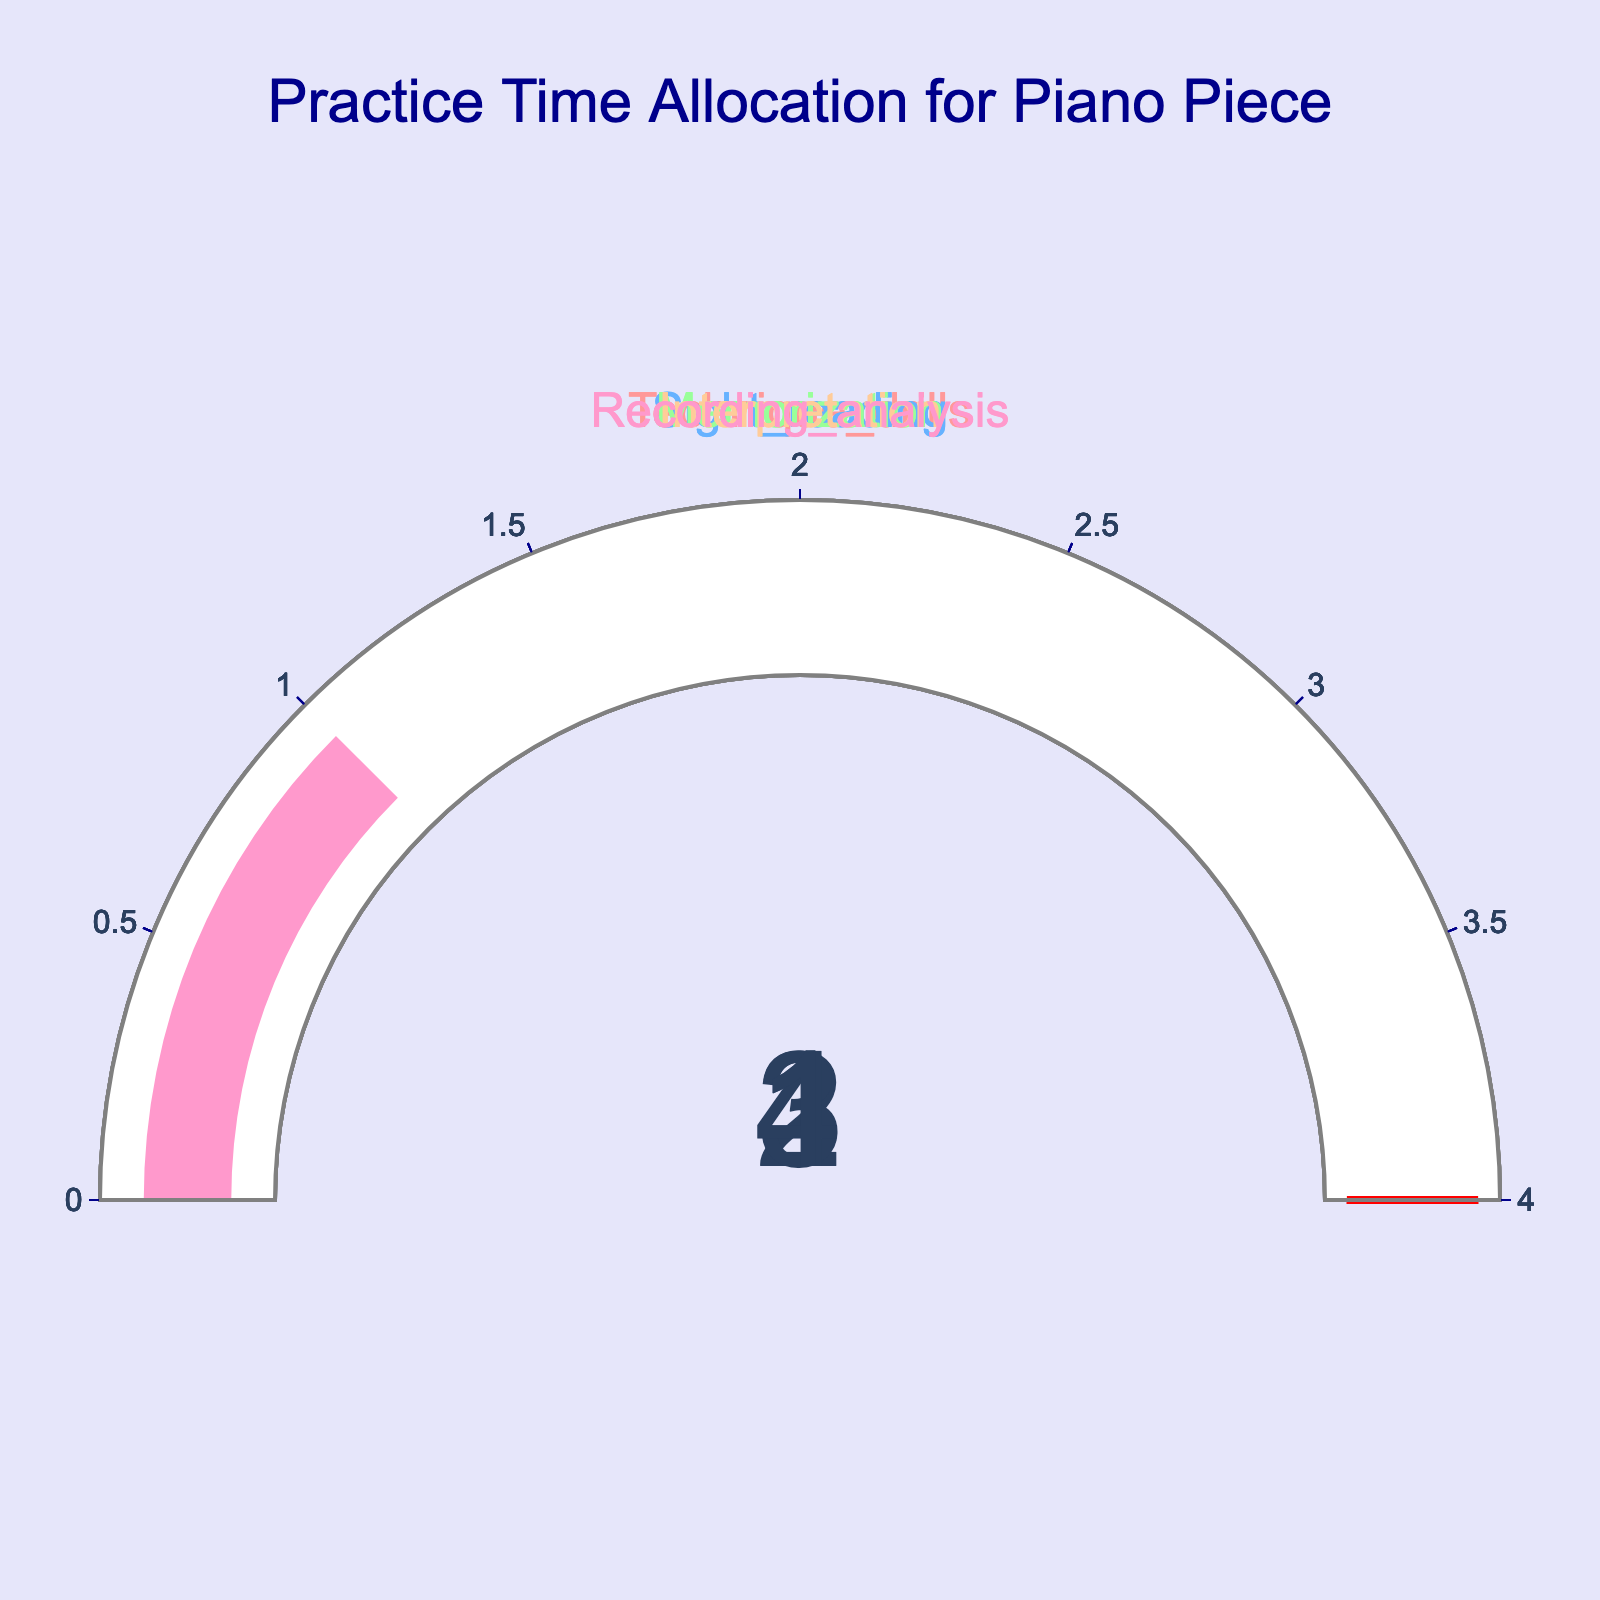What is the title of the figure? The title can be found at the top center of the figure, written in a large font and colored dark blue.
Answer: Practice Time Allocation for Piano Piece How many practice aspects are represented in the figure? Count the unique gauges, each representing a different practice aspect.
Answer: 5 Which practice aspect has the highest allocated hours? Compare the values displayed on each gauge. The aspect with the highest value is the one with the highest allocated hours.
Answer: Interpretation How many total hours are allocated across all practice aspects? Sum each value displayed on the gauges: 2 (Technique_drills) + 1 (Sight_reading) + 3 (Memorization) + 4 (Interpretation) + 1 (Recording_analysis).
Answer: 11 What color is used to represent the gauge with the fewest allocated hours? Identify the gauges with the smallest value (1 hour) and note their color.
Answer: Light Blue (Sight_reading), Light Pink (Recording_analysis) What is the range of hours displayed on the gauges? The range is the difference between the highest and lowest values on the gauges. The minimum is 1 hour and the maximum is 4 hours. So, the range is 4 - 1.
Answer: 3 Which two practice aspects have the same number of allocated hours? Look for gauges displaying the same value. Both 'Sight_reading' and 'Recording_analysis' show 1 hour.
Answer: Sight_reading and Recording_analysis Is Memorization allocated more or less time than Technique_drills? Check the values on the gauges for Memorization and Technique_drills. Compare 3 hours (Memorization) to 2 hours (Technique_drills).
Answer: More How many more hours are allocated to Interpretation than to Recording_analysis? Subtract the hours for Recording_analysis (1) from those for Interpretation (4).
Answer: 3 What is the average number of hours allocated per practice aspect? Calculate the total sum of hours (11) and divide by the number of aspects (5).
Answer: 2.2 